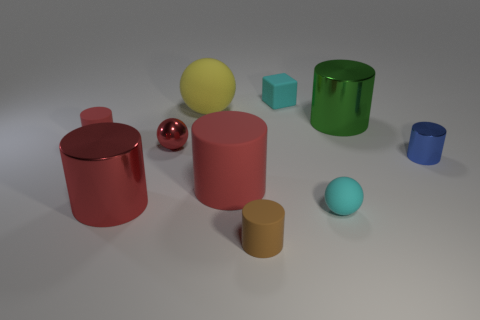Can you describe the lighting and shadows in the scene? The lighting in the image appears to be coming from the upper right corner, casting soft shadows toward the left. Each object has a distinct shadow that corresponds to its shape, indicating a single, consistent light source. 